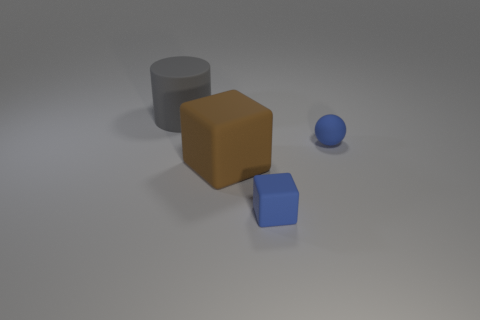Does the blue object behind the blue matte block have the same size as the block that is left of the tiny blue rubber cube? No, the blue object behind the blue matte block is larger in size than the block to the left of the tiny blue rubber cube. 